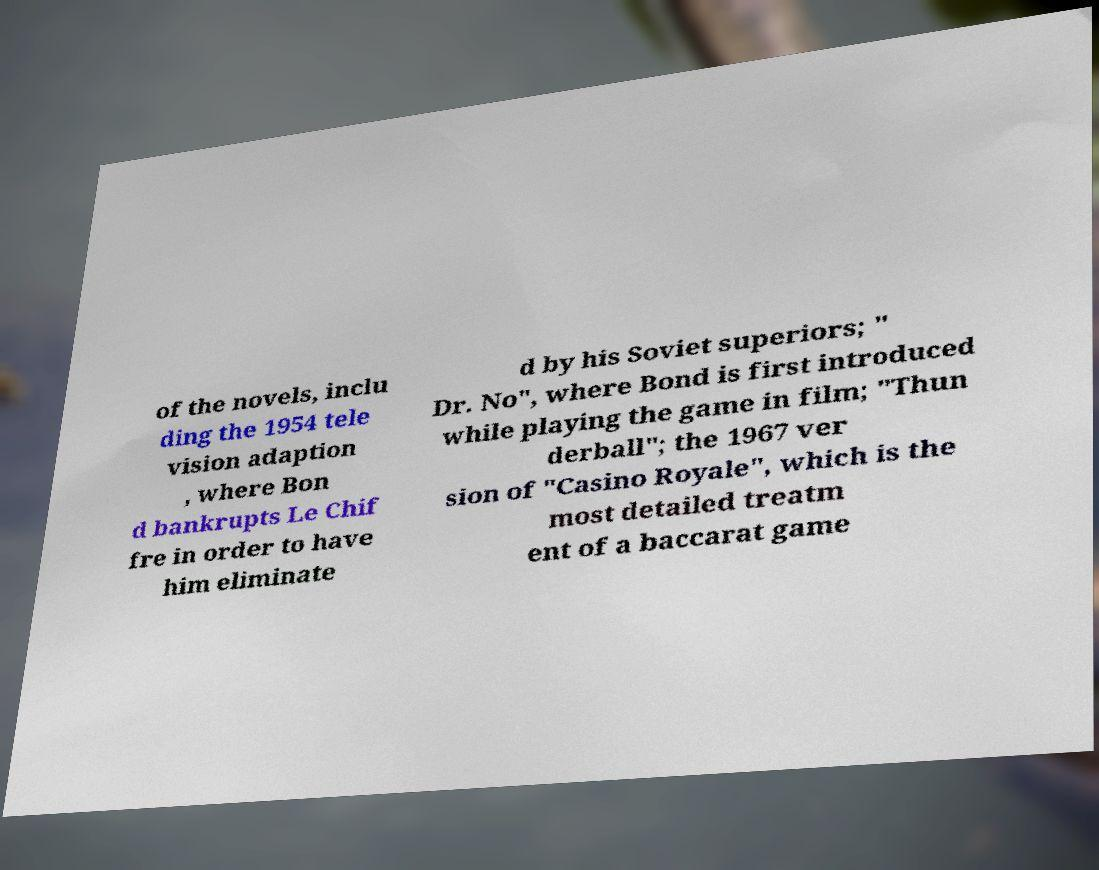Please read and relay the text visible in this image. What does it say? of the novels, inclu ding the 1954 tele vision adaption , where Bon d bankrupts Le Chif fre in order to have him eliminate d by his Soviet superiors; " Dr. No", where Bond is first introduced while playing the game in film; "Thun derball"; the 1967 ver sion of "Casino Royale", which is the most detailed treatm ent of a baccarat game 